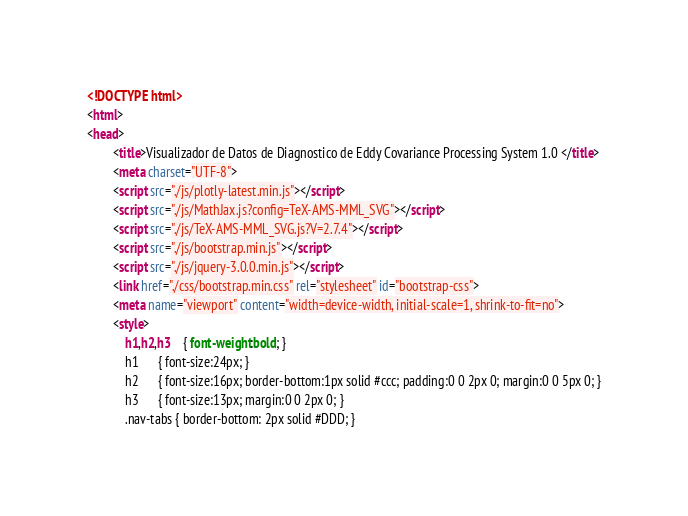<code> <loc_0><loc_0><loc_500><loc_500><_HTML_><!DOCTYPE html>
<html>
<head>
        <title>Visualizador de Datos de Diagnostico de Eddy Covariance Processing System 1.0 </title>
        <meta charset="UTF-8"> 
        <script src="./js/plotly-latest.min.js"></script>
        <script src="./js/MathJax.js?config=TeX-AMS-MML_SVG"></script>
        <script src="./js/TeX-AMS-MML_SVG.js?V=2.7.4"></script>
        <script src="./js/bootstrap.min.js"></script>
        <script src="./js/jquery-3.0.0.min.js"></script>
        <link href="./css/bootstrap.min.css" rel="stylesheet" id="bootstrap-css">
        <meta name="viewport" content="width=device-width, initial-scale=1, shrink-to-fit=no">
        <style>
        	h1,h2,h3	{ font-weight:bold; }
			h1		{ font-size:24px; }
			h2		{ font-size:16px; border-bottom:1px solid #ccc; padding:0 0 2px 0; margin:0 0 5px 0; }
			h3		{ font-size:13px; margin:0 0 2px 0; }
			.nav-tabs { border-bottom: 2px solid #DDD; }</code> 